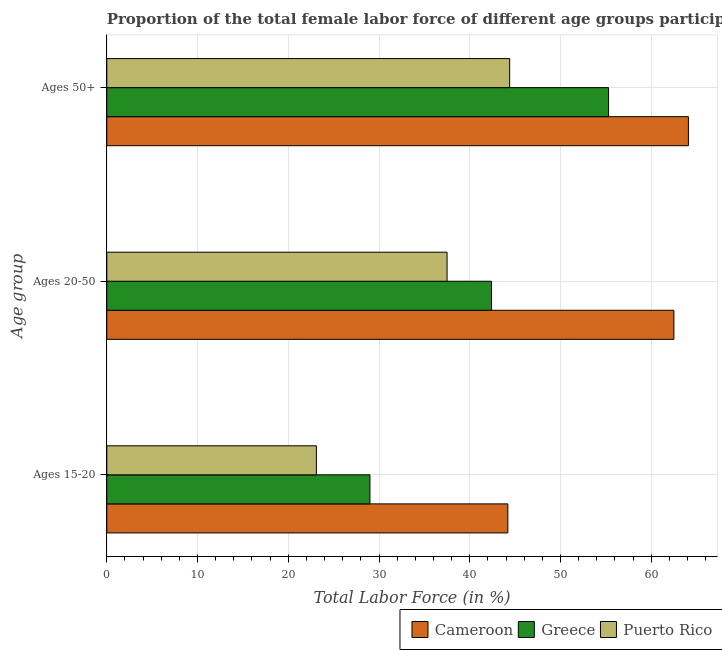How many groups of bars are there?
Provide a short and direct response. 3. What is the label of the 1st group of bars from the top?
Provide a short and direct response. Ages 50+. What is the percentage of female labor force within the age group 20-50 in Greece?
Offer a terse response. 42.4. Across all countries, what is the maximum percentage of female labor force within the age group 20-50?
Provide a succinct answer. 62.5. Across all countries, what is the minimum percentage of female labor force above age 50?
Provide a succinct answer. 44.4. In which country was the percentage of female labor force within the age group 20-50 maximum?
Your answer should be compact. Cameroon. In which country was the percentage of female labor force within the age group 20-50 minimum?
Offer a terse response. Puerto Rico. What is the total percentage of female labor force above age 50 in the graph?
Make the answer very short. 163.8. What is the difference between the percentage of female labor force above age 50 in Greece and that in Puerto Rico?
Provide a succinct answer. 10.9. What is the difference between the percentage of female labor force within the age group 15-20 in Cameroon and the percentage of female labor force within the age group 20-50 in Greece?
Keep it short and to the point. 1.8. What is the average percentage of female labor force above age 50 per country?
Ensure brevity in your answer.  54.6. What is the difference between the percentage of female labor force within the age group 20-50 and percentage of female labor force above age 50 in Cameroon?
Your answer should be very brief. -1.6. What is the ratio of the percentage of female labor force above age 50 in Puerto Rico to that in Cameroon?
Your response must be concise. 0.69. What is the difference between the highest and the second highest percentage of female labor force within the age group 15-20?
Provide a short and direct response. 15.2. What is the difference between the highest and the lowest percentage of female labor force within the age group 15-20?
Your answer should be very brief. 21.1. Is the sum of the percentage of female labor force above age 50 in Cameroon and Puerto Rico greater than the maximum percentage of female labor force within the age group 15-20 across all countries?
Offer a very short reply. Yes. What does the 3rd bar from the top in Ages 15-20 represents?
Offer a terse response. Cameroon. What does the 1st bar from the bottom in Ages 20-50 represents?
Ensure brevity in your answer.  Cameroon. Is it the case that in every country, the sum of the percentage of female labor force within the age group 15-20 and percentage of female labor force within the age group 20-50 is greater than the percentage of female labor force above age 50?
Ensure brevity in your answer.  Yes. Are all the bars in the graph horizontal?
Your response must be concise. Yes. Does the graph contain any zero values?
Keep it short and to the point. No. Does the graph contain grids?
Provide a succinct answer. Yes. What is the title of the graph?
Your answer should be compact. Proportion of the total female labor force of different age groups participating in production in 2007. What is the label or title of the Y-axis?
Your answer should be very brief. Age group. What is the Total Labor Force (in %) in Cameroon in Ages 15-20?
Give a very brief answer. 44.2. What is the Total Labor Force (in %) of Greece in Ages 15-20?
Your answer should be compact. 29. What is the Total Labor Force (in %) of Puerto Rico in Ages 15-20?
Offer a very short reply. 23.1. What is the Total Labor Force (in %) of Cameroon in Ages 20-50?
Your answer should be compact. 62.5. What is the Total Labor Force (in %) of Greece in Ages 20-50?
Your answer should be very brief. 42.4. What is the Total Labor Force (in %) in Puerto Rico in Ages 20-50?
Ensure brevity in your answer.  37.5. What is the Total Labor Force (in %) of Cameroon in Ages 50+?
Give a very brief answer. 64.1. What is the Total Labor Force (in %) of Greece in Ages 50+?
Ensure brevity in your answer.  55.3. What is the Total Labor Force (in %) of Puerto Rico in Ages 50+?
Give a very brief answer. 44.4. Across all Age group, what is the maximum Total Labor Force (in %) of Cameroon?
Offer a terse response. 64.1. Across all Age group, what is the maximum Total Labor Force (in %) in Greece?
Give a very brief answer. 55.3. Across all Age group, what is the maximum Total Labor Force (in %) in Puerto Rico?
Provide a short and direct response. 44.4. Across all Age group, what is the minimum Total Labor Force (in %) in Cameroon?
Offer a terse response. 44.2. Across all Age group, what is the minimum Total Labor Force (in %) of Greece?
Provide a succinct answer. 29. Across all Age group, what is the minimum Total Labor Force (in %) of Puerto Rico?
Provide a short and direct response. 23.1. What is the total Total Labor Force (in %) of Cameroon in the graph?
Offer a very short reply. 170.8. What is the total Total Labor Force (in %) of Greece in the graph?
Make the answer very short. 126.7. What is the total Total Labor Force (in %) in Puerto Rico in the graph?
Your response must be concise. 105. What is the difference between the Total Labor Force (in %) of Cameroon in Ages 15-20 and that in Ages 20-50?
Provide a succinct answer. -18.3. What is the difference between the Total Labor Force (in %) in Puerto Rico in Ages 15-20 and that in Ages 20-50?
Give a very brief answer. -14.4. What is the difference between the Total Labor Force (in %) in Cameroon in Ages 15-20 and that in Ages 50+?
Offer a terse response. -19.9. What is the difference between the Total Labor Force (in %) of Greece in Ages 15-20 and that in Ages 50+?
Provide a succinct answer. -26.3. What is the difference between the Total Labor Force (in %) in Puerto Rico in Ages 15-20 and that in Ages 50+?
Make the answer very short. -21.3. What is the difference between the Total Labor Force (in %) in Cameroon in Ages 20-50 and that in Ages 50+?
Give a very brief answer. -1.6. What is the difference between the Total Labor Force (in %) in Greece in Ages 20-50 and that in Ages 50+?
Give a very brief answer. -12.9. What is the difference between the Total Labor Force (in %) of Cameroon in Ages 15-20 and the Total Labor Force (in %) of Puerto Rico in Ages 50+?
Provide a short and direct response. -0.2. What is the difference between the Total Labor Force (in %) in Greece in Ages 15-20 and the Total Labor Force (in %) in Puerto Rico in Ages 50+?
Ensure brevity in your answer.  -15.4. What is the difference between the Total Labor Force (in %) in Cameroon in Ages 20-50 and the Total Labor Force (in %) in Greece in Ages 50+?
Offer a very short reply. 7.2. What is the difference between the Total Labor Force (in %) of Cameroon in Ages 20-50 and the Total Labor Force (in %) of Puerto Rico in Ages 50+?
Give a very brief answer. 18.1. What is the difference between the Total Labor Force (in %) in Greece in Ages 20-50 and the Total Labor Force (in %) in Puerto Rico in Ages 50+?
Your answer should be very brief. -2. What is the average Total Labor Force (in %) of Cameroon per Age group?
Your response must be concise. 56.93. What is the average Total Labor Force (in %) of Greece per Age group?
Make the answer very short. 42.23. What is the average Total Labor Force (in %) in Puerto Rico per Age group?
Offer a very short reply. 35. What is the difference between the Total Labor Force (in %) of Cameroon and Total Labor Force (in %) of Greece in Ages 15-20?
Ensure brevity in your answer.  15.2. What is the difference between the Total Labor Force (in %) of Cameroon and Total Labor Force (in %) of Puerto Rico in Ages 15-20?
Provide a short and direct response. 21.1. What is the difference between the Total Labor Force (in %) of Cameroon and Total Labor Force (in %) of Greece in Ages 20-50?
Make the answer very short. 20.1. What is the ratio of the Total Labor Force (in %) of Cameroon in Ages 15-20 to that in Ages 20-50?
Keep it short and to the point. 0.71. What is the ratio of the Total Labor Force (in %) in Greece in Ages 15-20 to that in Ages 20-50?
Provide a short and direct response. 0.68. What is the ratio of the Total Labor Force (in %) in Puerto Rico in Ages 15-20 to that in Ages 20-50?
Offer a very short reply. 0.62. What is the ratio of the Total Labor Force (in %) in Cameroon in Ages 15-20 to that in Ages 50+?
Give a very brief answer. 0.69. What is the ratio of the Total Labor Force (in %) of Greece in Ages 15-20 to that in Ages 50+?
Keep it short and to the point. 0.52. What is the ratio of the Total Labor Force (in %) of Puerto Rico in Ages 15-20 to that in Ages 50+?
Give a very brief answer. 0.52. What is the ratio of the Total Labor Force (in %) in Greece in Ages 20-50 to that in Ages 50+?
Offer a terse response. 0.77. What is the ratio of the Total Labor Force (in %) of Puerto Rico in Ages 20-50 to that in Ages 50+?
Give a very brief answer. 0.84. What is the difference between the highest and the second highest Total Labor Force (in %) of Cameroon?
Provide a succinct answer. 1.6. What is the difference between the highest and the second highest Total Labor Force (in %) in Greece?
Make the answer very short. 12.9. What is the difference between the highest and the lowest Total Labor Force (in %) in Cameroon?
Your answer should be very brief. 19.9. What is the difference between the highest and the lowest Total Labor Force (in %) in Greece?
Ensure brevity in your answer.  26.3. What is the difference between the highest and the lowest Total Labor Force (in %) in Puerto Rico?
Keep it short and to the point. 21.3. 